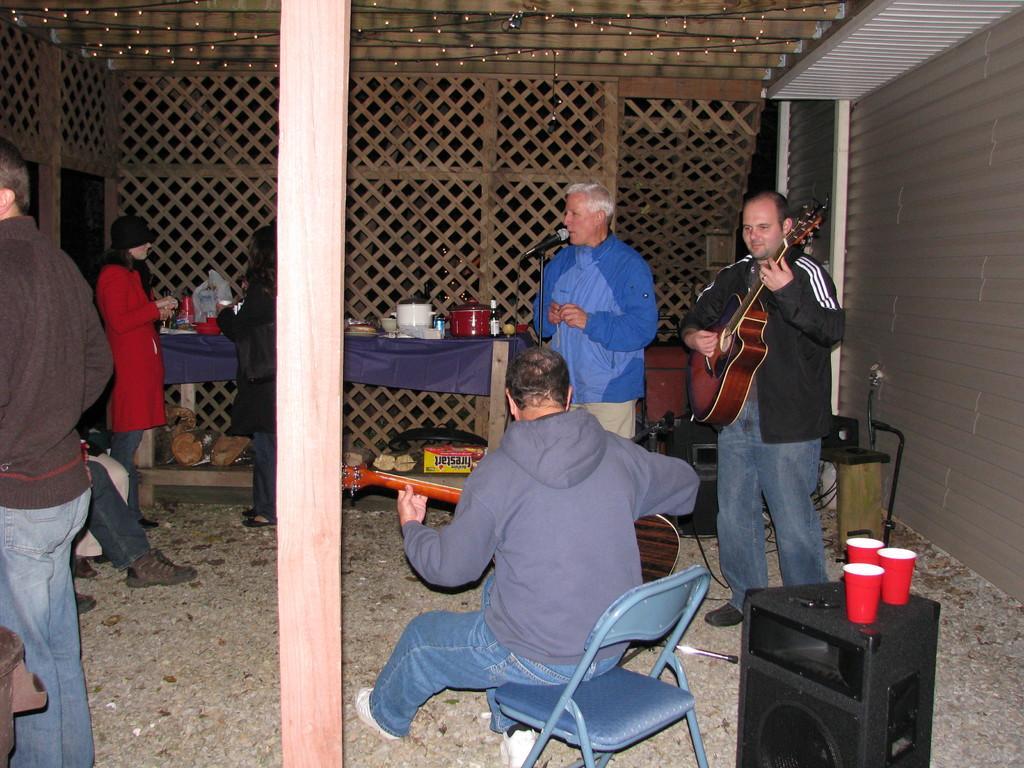Describe this image in one or two sentences. In this picture a guy is singing with a mic placed in front of him and to beside him there is a guy playing a guitar and we find a decorated wall in the background and the roof has lights. 